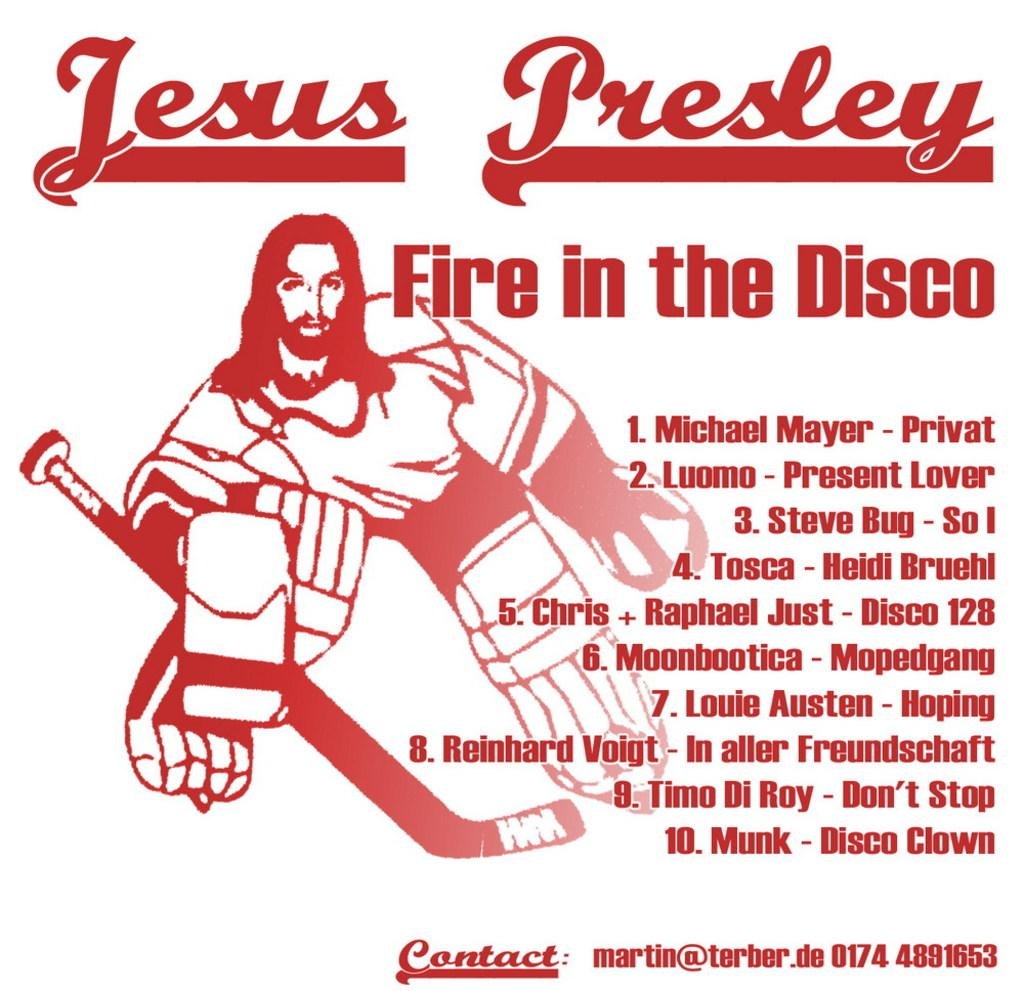Provide a one-sentence caption for the provided image. A poster for Jesus Presley Fire in the Disco with a picture of Jesus in hockey gear. 